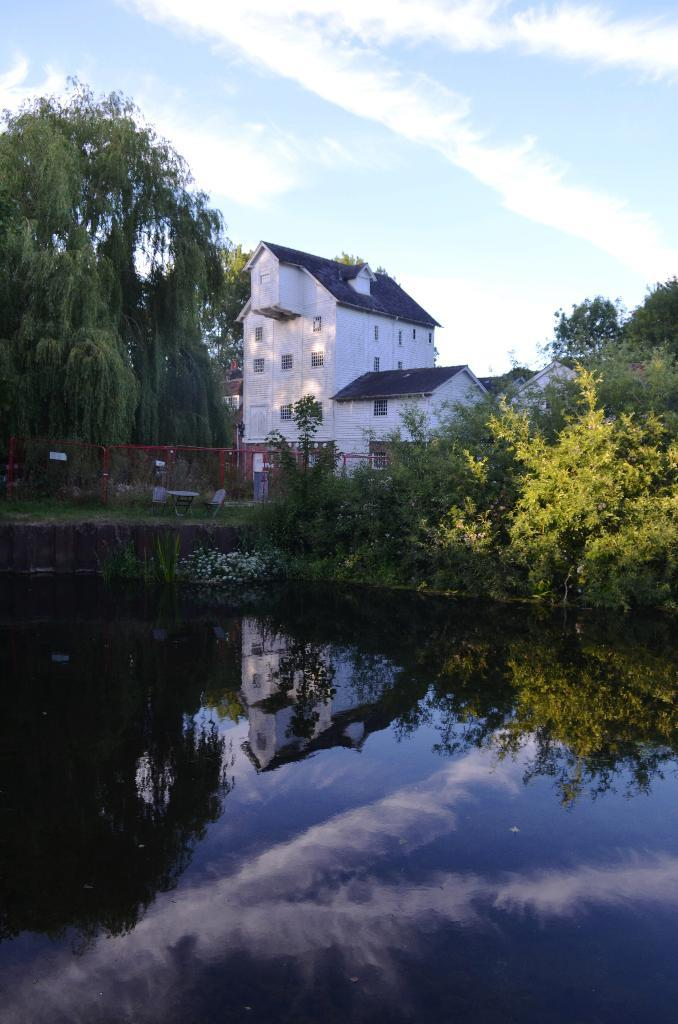What is located at the bottom of the image? There is a pound at the bottom of the image. What can be seen in the background of the image? There are houses, trees, and a fence in the background of the image. What is visible at the top of the image? The sky is visible at the top of the image. Can you tell me how many snakes are slithering around the pound in the image? There are no snakes present in the image; it features a pound with a background of houses, trees, and a fence. What type of beast can be seen interacting with the houses in the image? There is no beast present in the image; only the pound, houses, trees, fence, and sky are visible. 